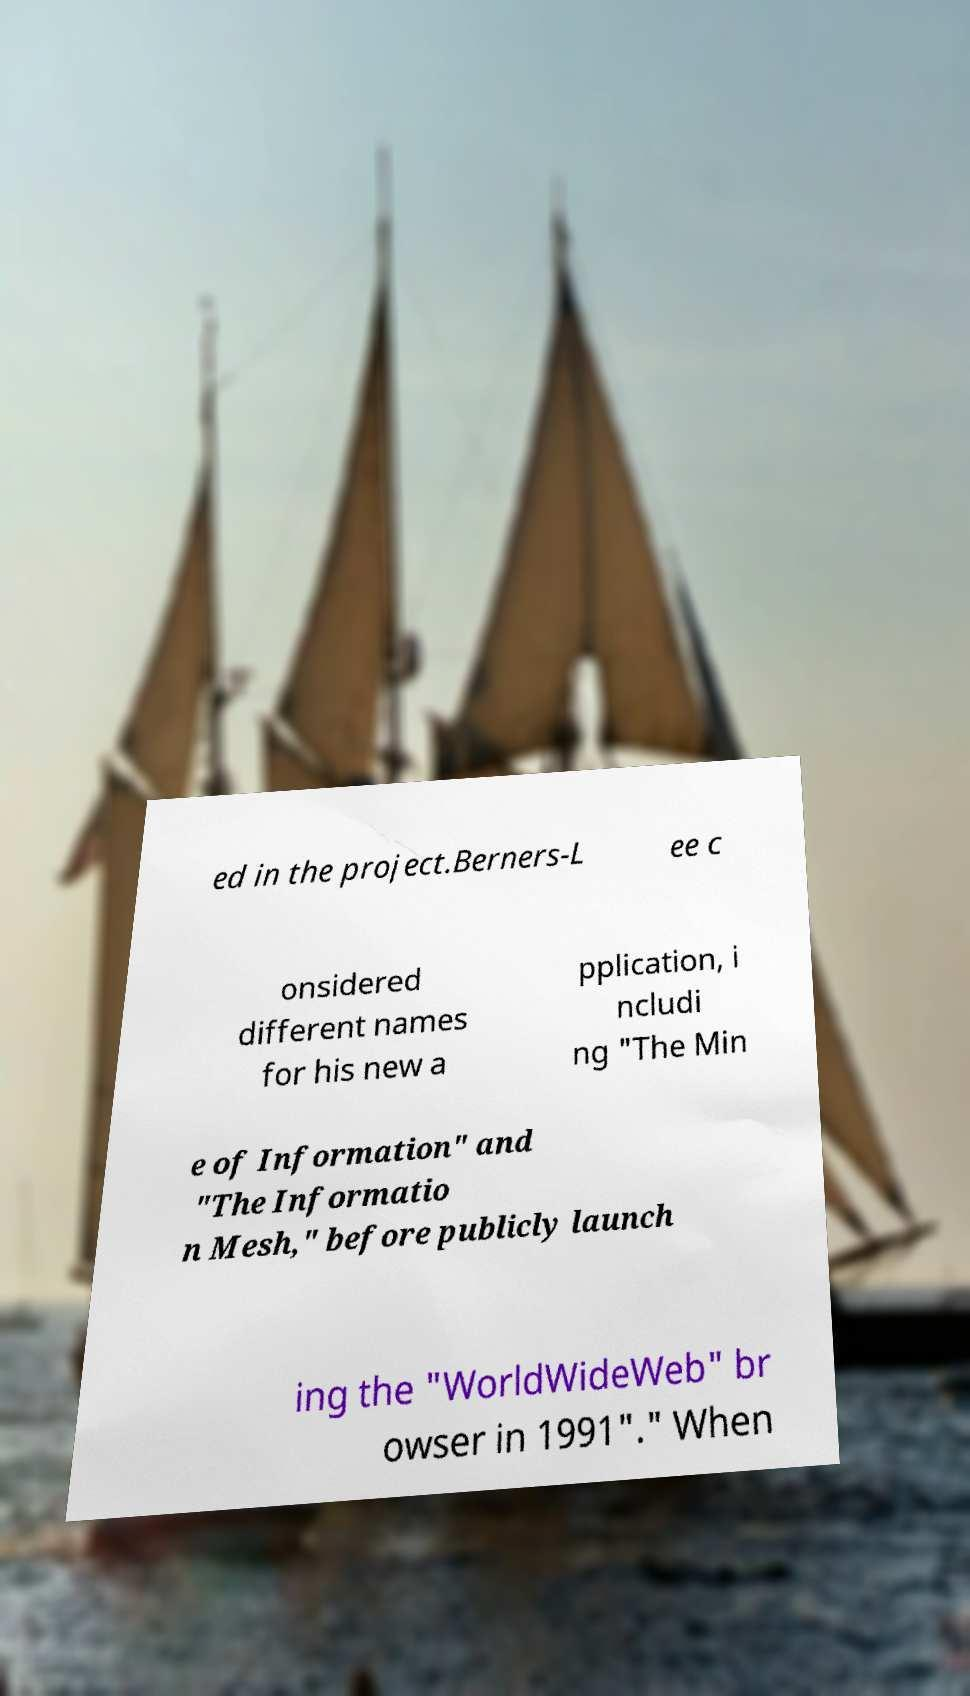Can you read and provide the text displayed in the image?This photo seems to have some interesting text. Can you extract and type it out for me? ed in the project.Berners-L ee c onsidered different names for his new a pplication, i ncludi ng "The Min e of Information" and "The Informatio n Mesh," before publicly launch ing the "WorldWideWeb" br owser in 1991"." When 